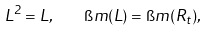Convert formula to latex. <formula><loc_0><loc_0><loc_500><loc_500>L ^ { 2 } = L , \quad \i m ( L ) = \i m ( R _ { t } ) ,</formula> 